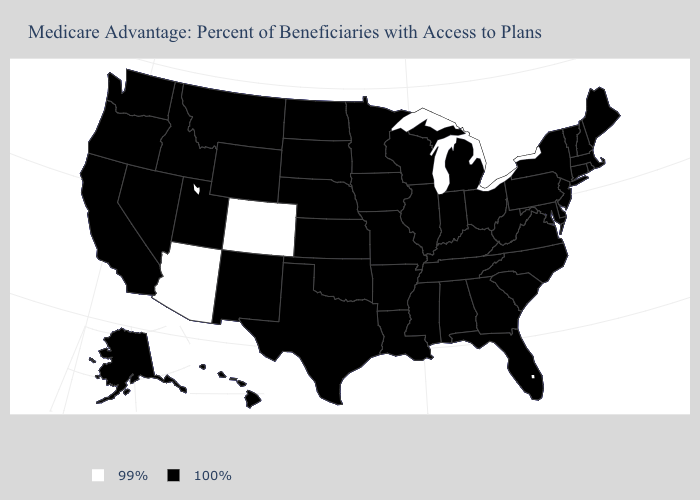Name the states that have a value in the range 99%?
Be succinct. Arizona, Colorado. Name the states that have a value in the range 99%?
Short answer required. Arizona, Colorado. Which states have the lowest value in the South?
Short answer required. Alabama, Arkansas, Delaware, Florida, Georgia, Kentucky, Louisiana, Maryland, Mississippi, North Carolina, Oklahoma, South Carolina, Tennessee, Texas, Virginia, West Virginia. What is the value of Alabama?
Be succinct. 100%. Name the states that have a value in the range 100%?
Short answer required. Alaska, Alabama, Arkansas, California, Connecticut, Delaware, Florida, Georgia, Hawaii, Iowa, Idaho, Illinois, Indiana, Kansas, Kentucky, Louisiana, Massachusetts, Maryland, Maine, Michigan, Minnesota, Missouri, Mississippi, Montana, North Carolina, North Dakota, Nebraska, New Hampshire, New Jersey, New Mexico, Nevada, New York, Ohio, Oklahoma, Oregon, Pennsylvania, Rhode Island, South Carolina, South Dakota, Tennessee, Texas, Utah, Virginia, Vermont, Washington, Wisconsin, West Virginia, Wyoming. What is the value of Alaska?
Short answer required. 100%. What is the value of Washington?
Quick response, please. 100%. What is the value of North Dakota?
Quick response, please. 100%. Does the map have missing data?
Write a very short answer. No. What is the value of Mississippi?
Quick response, please. 100%. What is the value of Massachusetts?
Give a very brief answer. 100%. What is the lowest value in the Northeast?
Answer briefly. 100%. What is the highest value in the MidWest ?
Concise answer only. 100%. Among the states that border Louisiana , which have the lowest value?
Short answer required. Arkansas, Mississippi, Texas. 